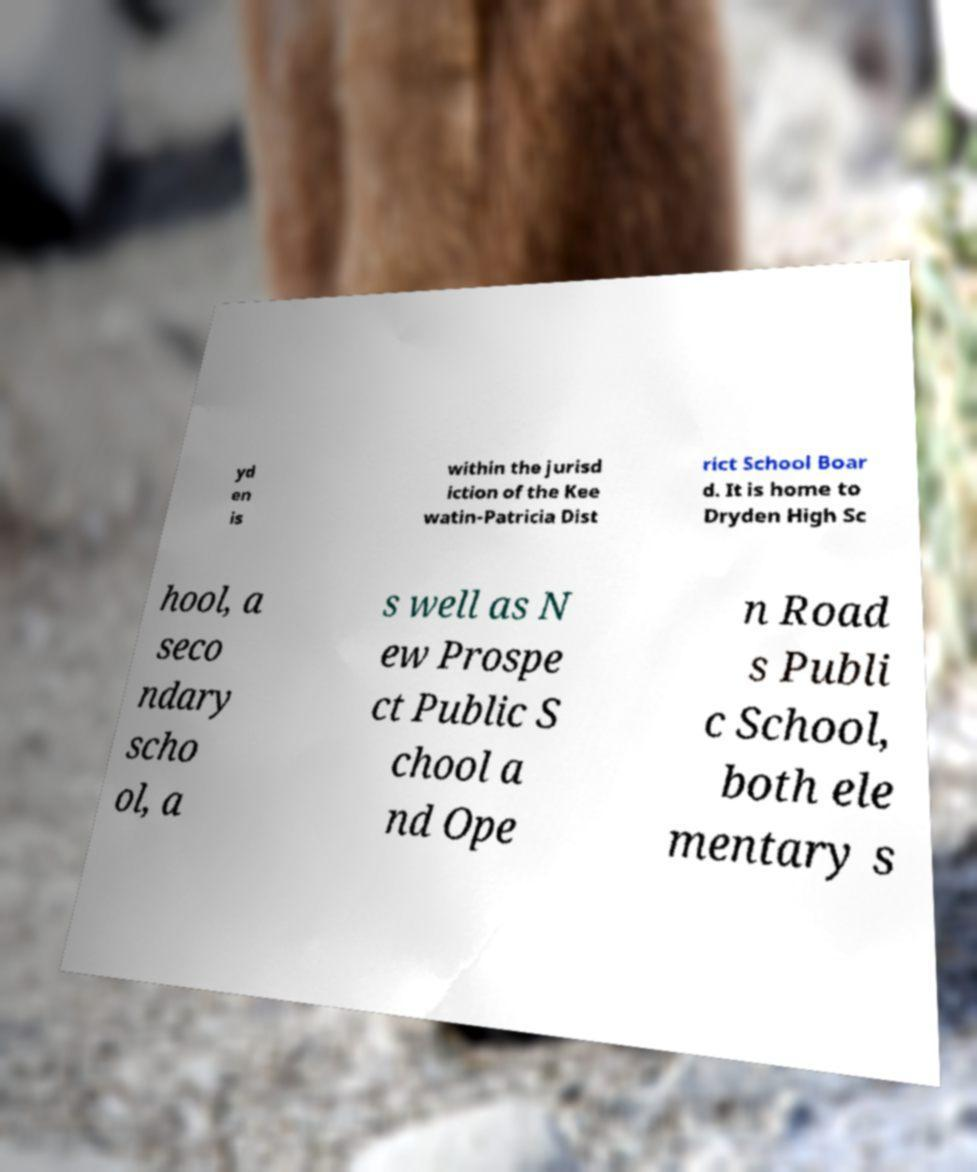What messages or text are displayed in this image? I need them in a readable, typed format. yd en is within the jurisd iction of the Kee watin-Patricia Dist rict School Boar d. It is home to Dryden High Sc hool, a seco ndary scho ol, a s well as N ew Prospe ct Public S chool a nd Ope n Road s Publi c School, both ele mentary s 